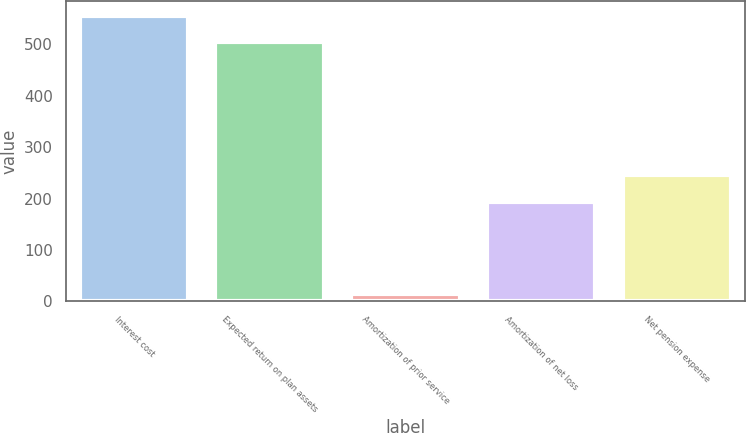Convert chart. <chart><loc_0><loc_0><loc_500><loc_500><bar_chart><fcel>Interest cost<fcel>Expected return on plan assets<fcel>Amortization of prior service<fcel>Amortization of net loss<fcel>Net pension expense<nl><fcel>555.6<fcel>504<fcel>14<fcel>194<fcel>245.6<nl></chart> 